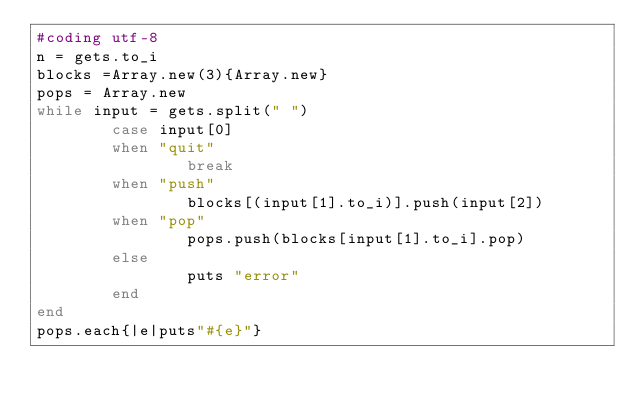Convert code to text. <code><loc_0><loc_0><loc_500><loc_500><_Ruby_>#coding utf-8
n = gets.to_i
blocks =Array.new(3){Array.new}
pops = Array.new
while input = gets.split(" ")
        case input[0]
        when "quit"
                break
        when "push"
                blocks[(input[1].to_i)].push(input[2])
        when "pop"
                pops.push(blocks[input[1].to_i].pop)
        else
                puts "error"
        end
end
pops.each{|e|puts"#{e}"}</code> 